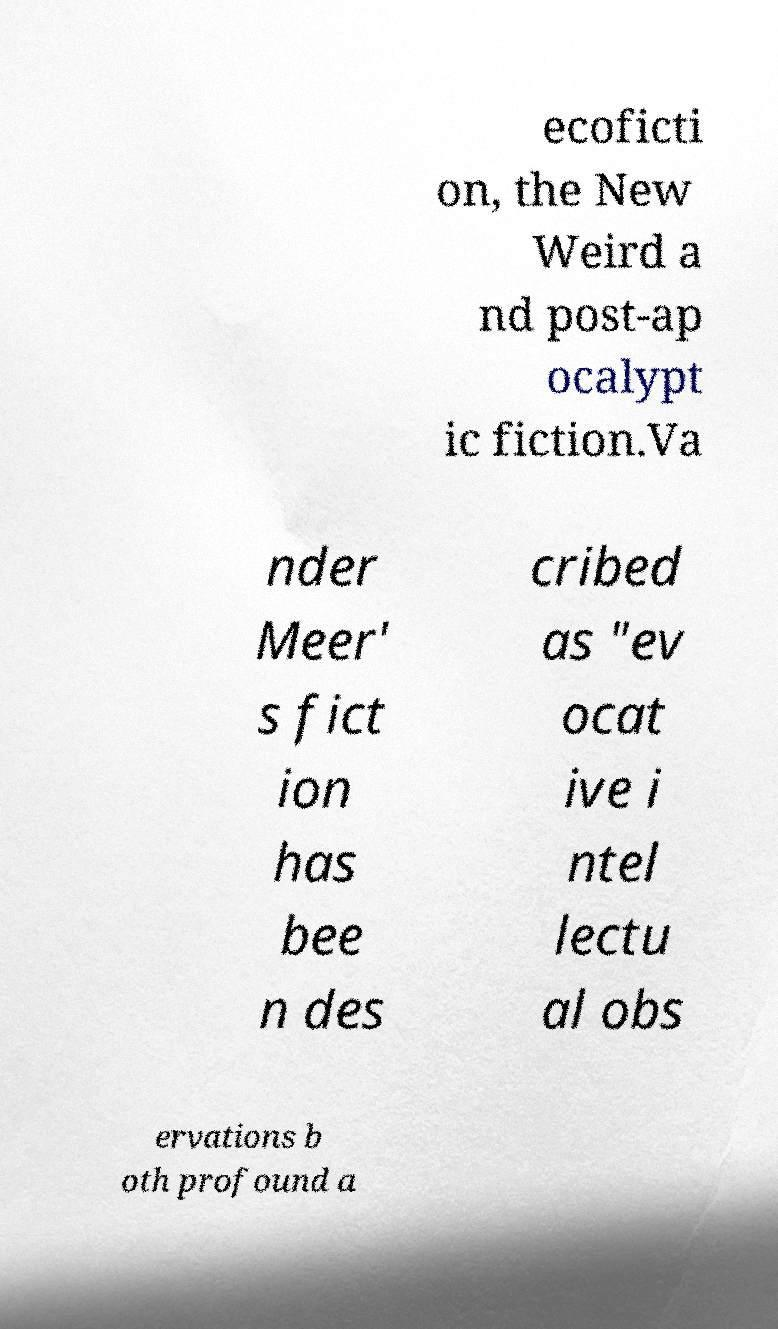Please identify and transcribe the text found in this image. ecoficti on, the New Weird a nd post-ap ocalypt ic fiction.Va nder Meer' s fict ion has bee n des cribed as "ev ocat ive i ntel lectu al obs ervations b oth profound a 